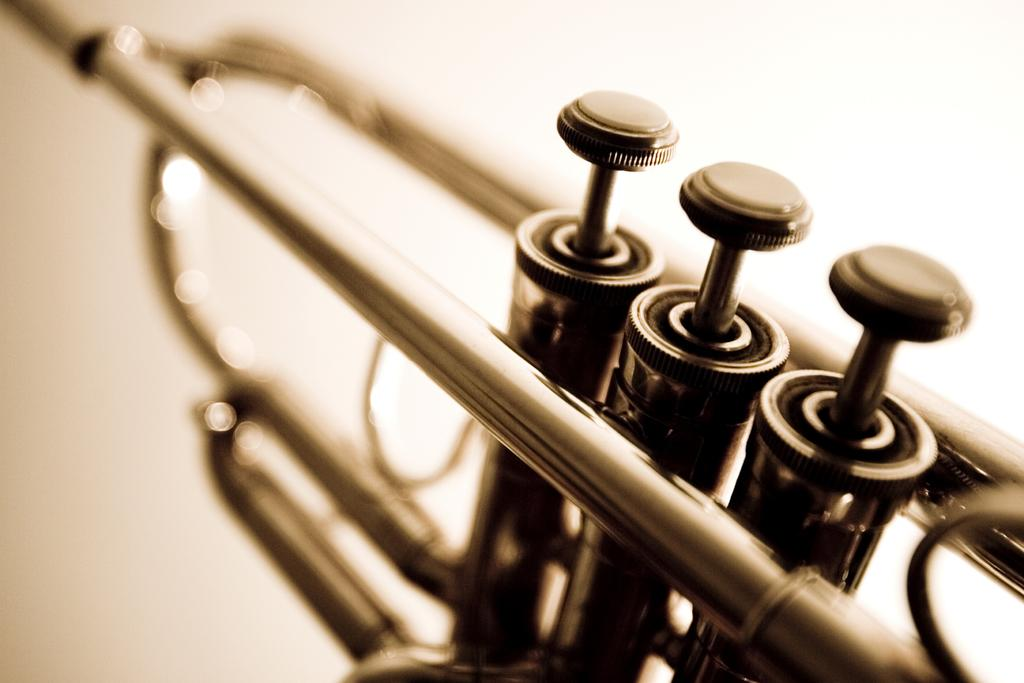What musical instrument is present in the image? There is a trumpet in the image. How many beds are visible in the image? There are no beds present in the image; it only features a trumpet. What type of flock can be seen flying in the background of the image? There is no flock or background visible in the image, as it only features a trumpet. 